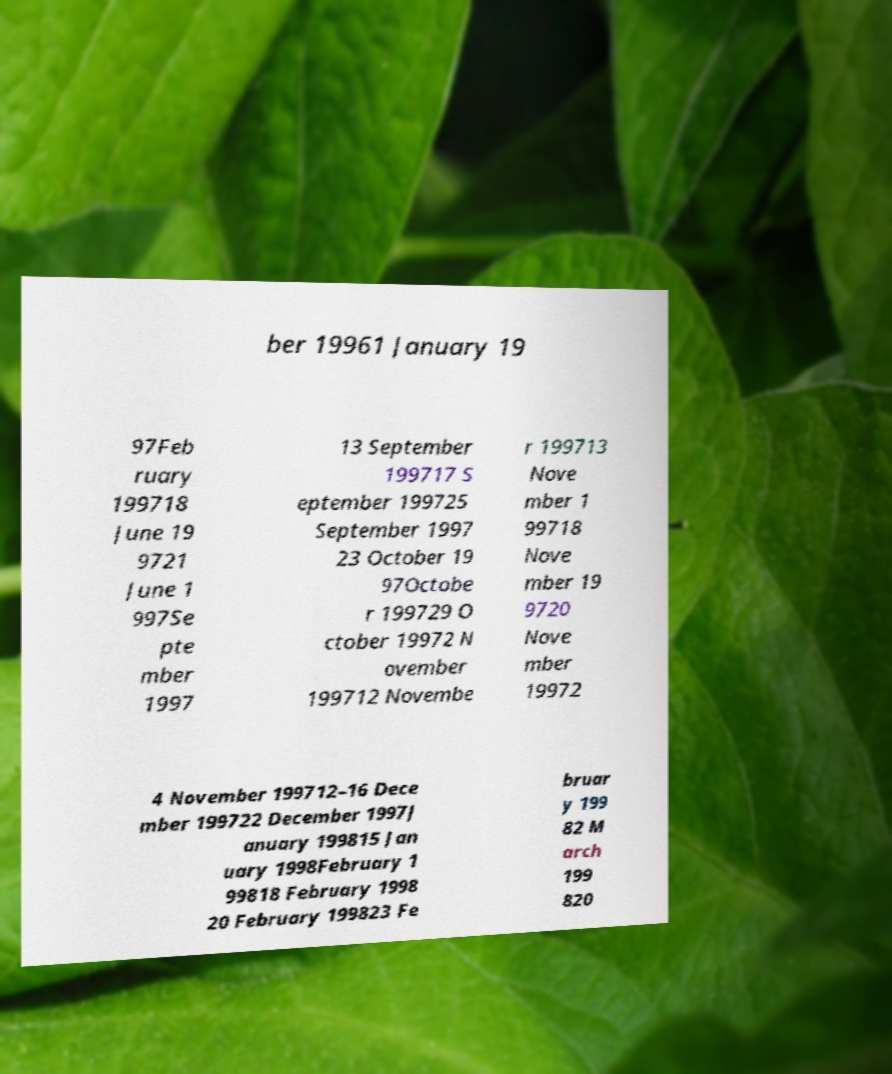Can you read and provide the text displayed in the image?This photo seems to have some interesting text. Can you extract and type it out for me? ber 19961 January 19 97Feb ruary 199718 June 19 9721 June 1 997Se pte mber 1997 13 September 199717 S eptember 199725 September 1997 23 October 19 97Octobe r 199729 O ctober 19972 N ovember 199712 Novembe r 199713 Nove mber 1 99718 Nove mber 19 9720 Nove mber 19972 4 November 199712–16 Dece mber 199722 December 1997J anuary 199815 Jan uary 1998February 1 99818 February 1998 20 February 199823 Fe bruar y 199 82 M arch 199 820 